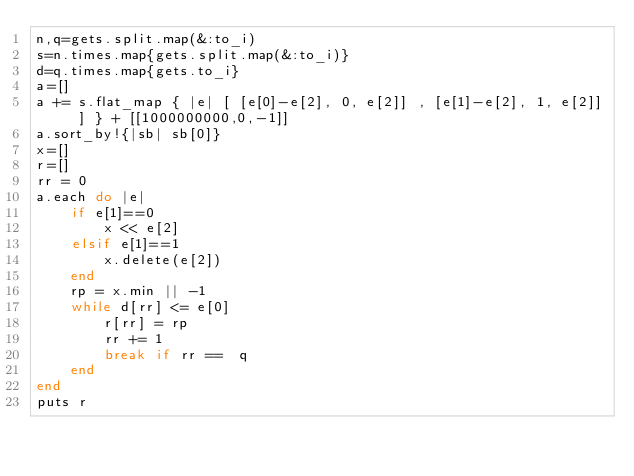Convert code to text. <code><loc_0><loc_0><loc_500><loc_500><_Ruby_>n,q=gets.split.map(&:to_i)
s=n.times.map{gets.split.map(&:to_i)}
d=q.times.map{gets.to_i}
a=[]
a += s.flat_map { |e| [ [e[0]-e[2], 0, e[2]] , [e[1]-e[2], 1, e[2]] ] } + [[1000000000,0,-1]]
a.sort_by!{|sb| sb[0]}
x=[]
r=[]
rr = 0
a.each do |e|
    if e[1]==0
        x << e[2]
    elsif e[1]==1
        x.delete(e[2])
    end
    rp = x.min || -1
    while d[rr] <= e[0]
        r[rr] = rp
        rr += 1
        break if rr ==  q
    end
end
puts r</code> 